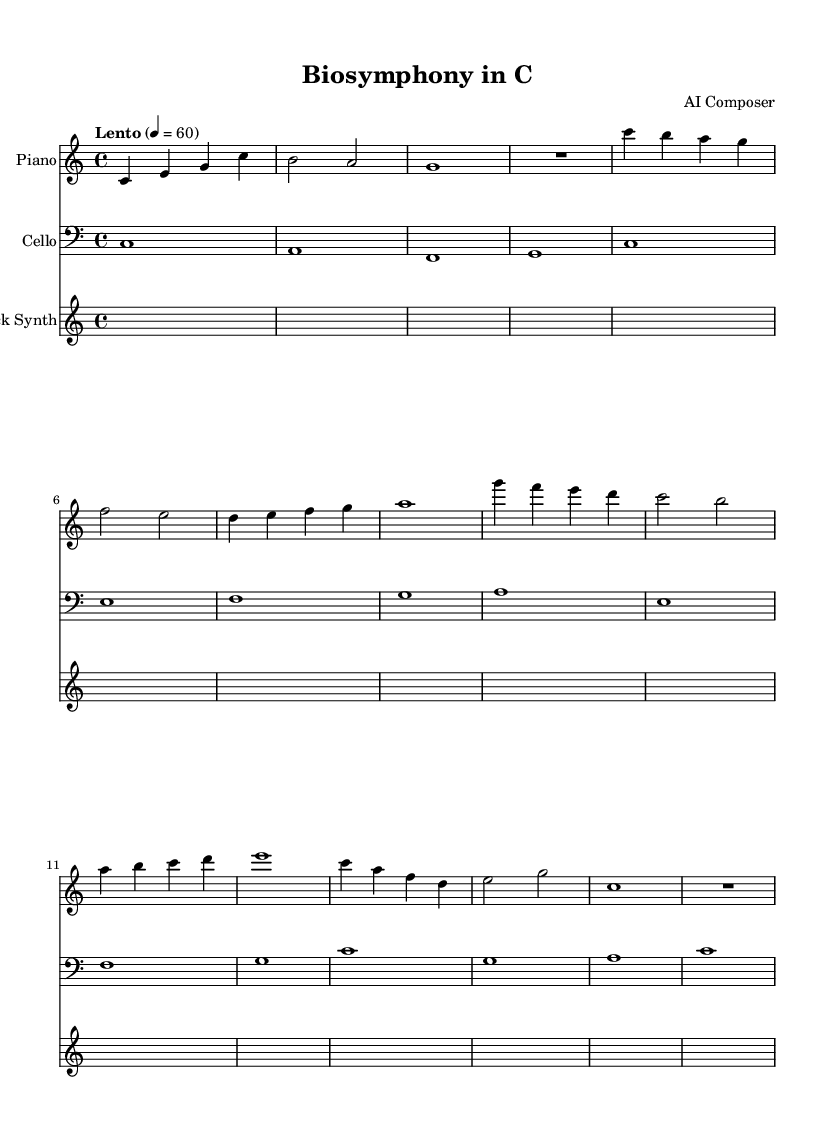what is the key signature of this music? The key signature is C major, which has no sharps or flats.
Answer: C major what is the time signature of this music? The time signature is indicated at the beginning of the score, showing four beats per measure.
Answer: 4/4 what is the tempo marking of this piece? The tempo marking at the beginning states "Lento," with a specific tempo of 60 beats per minute.
Answer: Lento 60 how many measures are in the piano part? By counting the measures in the piano part, we find that there are seven complete measures.
Answer: 7 which instruments are used in this piece? The instruments shown in the score are a piano, a cello, and a biofeedback synth.
Answer: Piano, Cello, Biofeedback Synth how does the biofeedback synth section start? The biofeedback synth section begins with a rest for one whole note duration, indicating silence before any sound is produced.
Answer: R1 in which section does the cello play its lowest note? The lowest note for the cello appears in the first measure as a C in the bass clef, which is the lowest note of the cello's range in this section.
Answer: C 